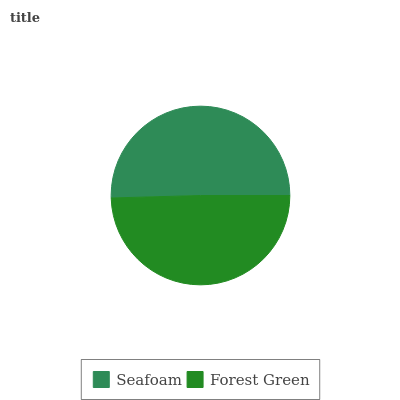Is Forest Green the minimum?
Answer yes or no. Yes. Is Seafoam the maximum?
Answer yes or no. Yes. Is Forest Green the maximum?
Answer yes or no. No. Is Seafoam greater than Forest Green?
Answer yes or no. Yes. Is Forest Green less than Seafoam?
Answer yes or no. Yes. Is Forest Green greater than Seafoam?
Answer yes or no. No. Is Seafoam less than Forest Green?
Answer yes or no. No. Is Seafoam the high median?
Answer yes or no. Yes. Is Forest Green the low median?
Answer yes or no. Yes. Is Forest Green the high median?
Answer yes or no. No. Is Seafoam the low median?
Answer yes or no. No. 